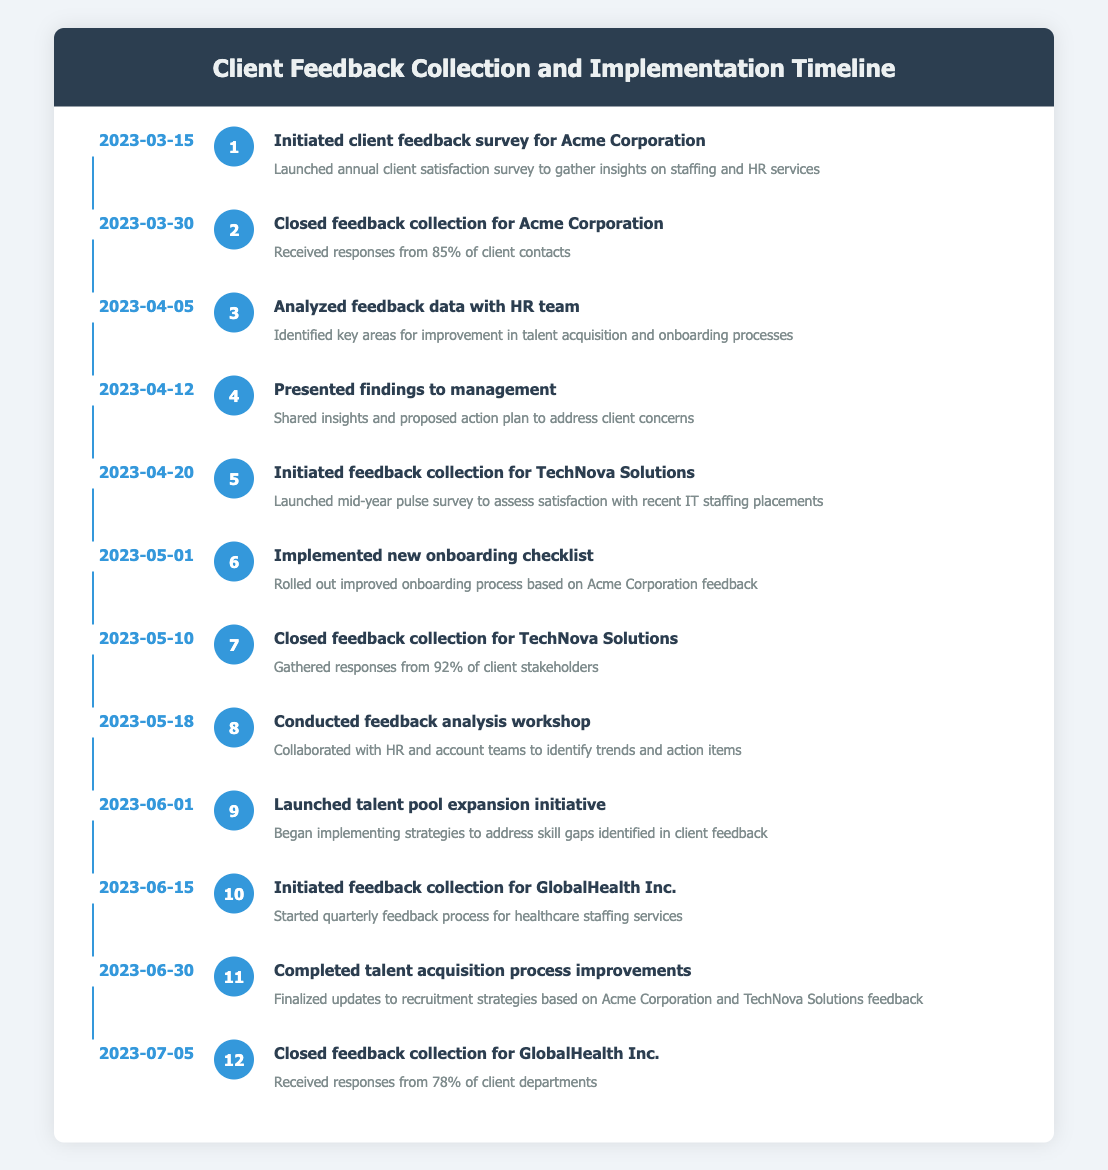What date did Acme Corporation's feedback survey begin? The timeline shows that the feedback survey for Acme Corporation was initiated on March 15, 2023.
Answer: March 15, 2023 How many client contacts responded to Acme Corporation's survey? On March 30, 2023, it is noted that 85% of client contacts responded to the feedback collection for Acme Corporation.
Answer: 85% What was the event that occurred on April 20, 2023? According to the timeline, the event on April 20, 2023, was the initiation of feedback collection for TechNova Solutions.
Answer: Initiated feedback collection for TechNova Solutions How many feedback collection processes were completed by June 30, 2023? By June 30, 2023, feedback collection was completed for Acme Corporation, TechNova Solutions, and GlobalHealth Inc., making it three processes in total.
Answer: 3 Was the feedback collection for TechNova Solutions closed before the analysis workshop? The feedback collection for TechNova Solutions was closed on May 10, 2023, while the analysis workshop took place on May 18, 2023, confirming that it was indeed closed beforehand.
Answer: Yes What percentage of GlobalHealth Inc. departments responded to the feedback collection? The timeline reveals that 78% of client departments responded to the feedback collection for GlobalHealth Inc. as closed on July 5, 2023.
Answer: 78% How many days passed between the initiation and closure of the feedback collection for Acme Corporation? The feedback collection for Acme Corporation was initiated on March 15, 2023, and closed on March 30, 2023. This is a duration of 15 days between the two dates.
Answer: 15 days What were the main areas identified for improvement after analyzing feedback data for Acme Corporation? The analysis of feedback data revealed key areas for improvement specifically in talent acquisition and onboarding processes, as noted on April 5, 2023.
Answer: Talent acquisition and onboarding processes How many surveys were launched before the talent pool expansion initiative? From the timeline, two surveys (for Acme Corporation and TechNova Solutions) were launched before the talent pool expansion initiative began on June 1, 2023.
Answer: 2 